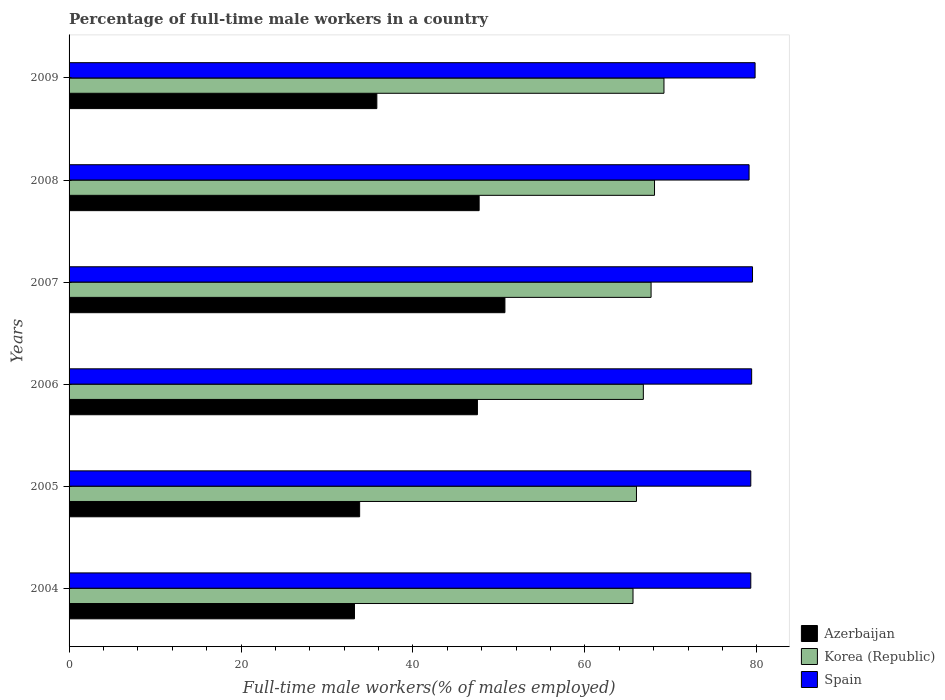How many groups of bars are there?
Make the answer very short. 6. How many bars are there on the 4th tick from the top?
Your response must be concise. 3. Across all years, what is the maximum percentage of full-time male workers in Spain?
Keep it short and to the point. 79.8. Across all years, what is the minimum percentage of full-time male workers in Spain?
Offer a terse response. 79.1. What is the total percentage of full-time male workers in Azerbaijan in the graph?
Ensure brevity in your answer.  248.7. What is the difference between the percentage of full-time male workers in Korea (Republic) in 2005 and that in 2007?
Offer a very short reply. -1.7. What is the difference between the percentage of full-time male workers in Azerbaijan in 2004 and the percentage of full-time male workers in Korea (Republic) in 2008?
Give a very brief answer. -34.9. What is the average percentage of full-time male workers in Korea (Republic) per year?
Keep it short and to the point. 67.23. In the year 2005, what is the difference between the percentage of full-time male workers in Korea (Republic) and percentage of full-time male workers in Spain?
Your answer should be compact. -13.3. In how many years, is the percentage of full-time male workers in Azerbaijan greater than 36 %?
Your answer should be compact. 3. What is the ratio of the percentage of full-time male workers in Korea (Republic) in 2006 to that in 2007?
Provide a succinct answer. 0.99. Is the sum of the percentage of full-time male workers in Spain in 2004 and 2009 greater than the maximum percentage of full-time male workers in Azerbaijan across all years?
Ensure brevity in your answer.  Yes. What does the 1st bar from the top in 2006 represents?
Your answer should be compact. Spain. What does the 1st bar from the bottom in 2007 represents?
Your response must be concise. Azerbaijan. Are all the bars in the graph horizontal?
Give a very brief answer. Yes. Does the graph contain any zero values?
Give a very brief answer. No. How many legend labels are there?
Provide a short and direct response. 3. What is the title of the graph?
Your answer should be compact. Percentage of full-time male workers in a country. What is the label or title of the X-axis?
Make the answer very short. Full-time male workers(% of males employed). What is the label or title of the Y-axis?
Keep it short and to the point. Years. What is the Full-time male workers(% of males employed) of Azerbaijan in 2004?
Keep it short and to the point. 33.2. What is the Full-time male workers(% of males employed) of Korea (Republic) in 2004?
Your answer should be compact. 65.6. What is the Full-time male workers(% of males employed) of Spain in 2004?
Provide a succinct answer. 79.3. What is the Full-time male workers(% of males employed) in Azerbaijan in 2005?
Give a very brief answer. 33.8. What is the Full-time male workers(% of males employed) of Spain in 2005?
Your response must be concise. 79.3. What is the Full-time male workers(% of males employed) in Azerbaijan in 2006?
Provide a short and direct response. 47.5. What is the Full-time male workers(% of males employed) in Korea (Republic) in 2006?
Make the answer very short. 66.8. What is the Full-time male workers(% of males employed) in Spain in 2006?
Offer a terse response. 79.4. What is the Full-time male workers(% of males employed) in Azerbaijan in 2007?
Make the answer very short. 50.7. What is the Full-time male workers(% of males employed) in Korea (Republic) in 2007?
Offer a terse response. 67.7. What is the Full-time male workers(% of males employed) of Spain in 2007?
Your answer should be very brief. 79.5. What is the Full-time male workers(% of males employed) of Azerbaijan in 2008?
Your answer should be compact. 47.7. What is the Full-time male workers(% of males employed) in Korea (Republic) in 2008?
Your response must be concise. 68.1. What is the Full-time male workers(% of males employed) of Spain in 2008?
Provide a short and direct response. 79.1. What is the Full-time male workers(% of males employed) of Azerbaijan in 2009?
Ensure brevity in your answer.  35.8. What is the Full-time male workers(% of males employed) of Korea (Republic) in 2009?
Give a very brief answer. 69.2. What is the Full-time male workers(% of males employed) in Spain in 2009?
Provide a succinct answer. 79.8. Across all years, what is the maximum Full-time male workers(% of males employed) of Azerbaijan?
Ensure brevity in your answer.  50.7. Across all years, what is the maximum Full-time male workers(% of males employed) in Korea (Republic)?
Offer a terse response. 69.2. Across all years, what is the maximum Full-time male workers(% of males employed) of Spain?
Give a very brief answer. 79.8. Across all years, what is the minimum Full-time male workers(% of males employed) in Azerbaijan?
Your answer should be compact. 33.2. Across all years, what is the minimum Full-time male workers(% of males employed) in Korea (Republic)?
Give a very brief answer. 65.6. Across all years, what is the minimum Full-time male workers(% of males employed) in Spain?
Give a very brief answer. 79.1. What is the total Full-time male workers(% of males employed) in Azerbaijan in the graph?
Give a very brief answer. 248.7. What is the total Full-time male workers(% of males employed) of Korea (Republic) in the graph?
Your answer should be very brief. 403.4. What is the total Full-time male workers(% of males employed) of Spain in the graph?
Give a very brief answer. 476.4. What is the difference between the Full-time male workers(% of males employed) of Azerbaijan in 2004 and that in 2005?
Your response must be concise. -0.6. What is the difference between the Full-time male workers(% of males employed) of Korea (Republic) in 2004 and that in 2005?
Ensure brevity in your answer.  -0.4. What is the difference between the Full-time male workers(% of males employed) of Azerbaijan in 2004 and that in 2006?
Offer a terse response. -14.3. What is the difference between the Full-time male workers(% of males employed) of Korea (Republic) in 2004 and that in 2006?
Provide a short and direct response. -1.2. What is the difference between the Full-time male workers(% of males employed) of Spain in 2004 and that in 2006?
Your response must be concise. -0.1. What is the difference between the Full-time male workers(% of males employed) of Azerbaijan in 2004 and that in 2007?
Your answer should be very brief. -17.5. What is the difference between the Full-time male workers(% of males employed) in Spain in 2004 and that in 2007?
Offer a very short reply. -0.2. What is the difference between the Full-time male workers(% of males employed) of Azerbaijan in 2004 and that in 2008?
Offer a terse response. -14.5. What is the difference between the Full-time male workers(% of males employed) in Spain in 2004 and that in 2008?
Ensure brevity in your answer.  0.2. What is the difference between the Full-time male workers(% of males employed) in Azerbaijan in 2004 and that in 2009?
Keep it short and to the point. -2.6. What is the difference between the Full-time male workers(% of males employed) of Spain in 2004 and that in 2009?
Provide a short and direct response. -0.5. What is the difference between the Full-time male workers(% of males employed) of Azerbaijan in 2005 and that in 2006?
Your answer should be compact. -13.7. What is the difference between the Full-time male workers(% of males employed) of Azerbaijan in 2005 and that in 2007?
Offer a terse response. -16.9. What is the difference between the Full-time male workers(% of males employed) in Korea (Republic) in 2005 and that in 2007?
Your response must be concise. -1.7. What is the difference between the Full-time male workers(% of males employed) of Azerbaijan in 2005 and that in 2009?
Your response must be concise. -2. What is the difference between the Full-time male workers(% of males employed) of Azerbaijan in 2006 and that in 2008?
Your answer should be compact. -0.2. What is the difference between the Full-time male workers(% of males employed) of Korea (Republic) in 2006 and that in 2008?
Keep it short and to the point. -1.3. What is the difference between the Full-time male workers(% of males employed) in Spain in 2006 and that in 2008?
Offer a very short reply. 0.3. What is the difference between the Full-time male workers(% of males employed) of Spain in 2006 and that in 2009?
Provide a short and direct response. -0.4. What is the difference between the Full-time male workers(% of males employed) of Azerbaijan in 2007 and that in 2008?
Your answer should be very brief. 3. What is the difference between the Full-time male workers(% of males employed) in Azerbaijan in 2007 and that in 2009?
Offer a very short reply. 14.9. What is the difference between the Full-time male workers(% of males employed) of Korea (Republic) in 2007 and that in 2009?
Make the answer very short. -1.5. What is the difference between the Full-time male workers(% of males employed) of Spain in 2007 and that in 2009?
Provide a succinct answer. -0.3. What is the difference between the Full-time male workers(% of males employed) of Azerbaijan in 2008 and that in 2009?
Give a very brief answer. 11.9. What is the difference between the Full-time male workers(% of males employed) of Spain in 2008 and that in 2009?
Ensure brevity in your answer.  -0.7. What is the difference between the Full-time male workers(% of males employed) of Azerbaijan in 2004 and the Full-time male workers(% of males employed) of Korea (Republic) in 2005?
Provide a short and direct response. -32.8. What is the difference between the Full-time male workers(% of males employed) of Azerbaijan in 2004 and the Full-time male workers(% of males employed) of Spain in 2005?
Keep it short and to the point. -46.1. What is the difference between the Full-time male workers(% of males employed) in Korea (Republic) in 2004 and the Full-time male workers(% of males employed) in Spain in 2005?
Ensure brevity in your answer.  -13.7. What is the difference between the Full-time male workers(% of males employed) in Azerbaijan in 2004 and the Full-time male workers(% of males employed) in Korea (Republic) in 2006?
Make the answer very short. -33.6. What is the difference between the Full-time male workers(% of males employed) of Azerbaijan in 2004 and the Full-time male workers(% of males employed) of Spain in 2006?
Provide a succinct answer. -46.2. What is the difference between the Full-time male workers(% of males employed) in Azerbaijan in 2004 and the Full-time male workers(% of males employed) in Korea (Republic) in 2007?
Your response must be concise. -34.5. What is the difference between the Full-time male workers(% of males employed) in Azerbaijan in 2004 and the Full-time male workers(% of males employed) in Spain in 2007?
Your answer should be very brief. -46.3. What is the difference between the Full-time male workers(% of males employed) in Azerbaijan in 2004 and the Full-time male workers(% of males employed) in Korea (Republic) in 2008?
Provide a short and direct response. -34.9. What is the difference between the Full-time male workers(% of males employed) of Azerbaijan in 2004 and the Full-time male workers(% of males employed) of Spain in 2008?
Ensure brevity in your answer.  -45.9. What is the difference between the Full-time male workers(% of males employed) of Korea (Republic) in 2004 and the Full-time male workers(% of males employed) of Spain in 2008?
Offer a very short reply. -13.5. What is the difference between the Full-time male workers(% of males employed) in Azerbaijan in 2004 and the Full-time male workers(% of males employed) in Korea (Republic) in 2009?
Provide a short and direct response. -36. What is the difference between the Full-time male workers(% of males employed) in Azerbaijan in 2004 and the Full-time male workers(% of males employed) in Spain in 2009?
Keep it short and to the point. -46.6. What is the difference between the Full-time male workers(% of males employed) in Azerbaijan in 2005 and the Full-time male workers(% of males employed) in Korea (Republic) in 2006?
Make the answer very short. -33. What is the difference between the Full-time male workers(% of males employed) of Azerbaijan in 2005 and the Full-time male workers(% of males employed) of Spain in 2006?
Offer a terse response. -45.6. What is the difference between the Full-time male workers(% of males employed) in Azerbaijan in 2005 and the Full-time male workers(% of males employed) in Korea (Republic) in 2007?
Your answer should be compact. -33.9. What is the difference between the Full-time male workers(% of males employed) of Azerbaijan in 2005 and the Full-time male workers(% of males employed) of Spain in 2007?
Give a very brief answer. -45.7. What is the difference between the Full-time male workers(% of males employed) in Azerbaijan in 2005 and the Full-time male workers(% of males employed) in Korea (Republic) in 2008?
Keep it short and to the point. -34.3. What is the difference between the Full-time male workers(% of males employed) of Azerbaijan in 2005 and the Full-time male workers(% of males employed) of Spain in 2008?
Provide a short and direct response. -45.3. What is the difference between the Full-time male workers(% of males employed) in Azerbaijan in 2005 and the Full-time male workers(% of males employed) in Korea (Republic) in 2009?
Offer a very short reply. -35.4. What is the difference between the Full-time male workers(% of males employed) in Azerbaijan in 2005 and the Full-time male workers(% of males employed) in Spain in 2009?
Your response must be concise. -46. What is the difference between the Full-time male workers(% of males employed) in Azerbaijan in 2006 and the Full-time male workers(% of males employed) in Korea (Republic) in 2007?
Your answer should be compact. -20.2. What is the difference between the Full-time male workers(% of males employed) of Azerbaijan in 2006 and the Full-time male workers(% of males employed) of Spain in 2007?
Provide a succinct answer. -32. What is the difference between the Full-time male workers(% of males employed) in Azerbaijan in 2006 and the Full-time male workers(% of males employed) in Korea (Republic) in 2008?
Ensure brevity in your answer.  -20.6. What is the difference between the Full-time male workers(% of males employed) in Azerbaijan in 2006 and the Full-time male workers(% of males employed) in Spain in 2008?
Provide a short and direct response. -31.6. What is the difference between the Full-time male workers(% of males employed) of Azerbaijan in 2006 and the Full-time male workers(% of males employed) of Korea (Republic) in 2009?
Your answer should be very brief. -21.7. What is the difference between the Full-time male workers(% of males employed) in Azerbaijan in 2006 and the Full-time male workers(% of males employed) in Spain in 2009?
Offer a terse response. -32.3. What is the difference between the Full-time male workers(% of males employed) of Korea (Republic) in 2006 and the Full-time male workers(% of males employed) of Spain in 2009?
Provide a short and direct response. -13. What is the difference between the Full-time male workers(% of males employed) in Azerbaijan in 2007 and the Full-time male workers(% of males employed) in Korea (Republic) in 2008?
Provide a short and direct response. -17.4. What is the difference between the Full-time male workers(% of males employed) in Azerbaijan in 2007 and the Full-time male workers(% of males employed) in Spain in 2008?
Give a very brief answer. -28.4. What is the difference between the Full-time male workers(% of males employed) in Korea (Republic) in 2007 and the Full-time male workers(% of males employed) in Spain in 2008?
Your answer should be compact. -11.4. What is the difference between the Full-time male workers(% of males employed) of Azerbaijan in 2007 and the Full-time male workers(% of males employed) of Korea (Republic) in 2009?
Your answer should be very brief. -18.5. What is the difference between the Full-time male workers(% of males employed) in Azerbaijan in 2007 and the Full-time male workers(% of males employed) in Spain in 2009?
Make the answer very short. -29.1. What is the difference between the Full-time male workers(% of males employed) in Korea (Republic) in 2007 and the Full-time male workers(% of males employed) in Spain in 2009?
Provide a succinct answer. -12.1. What is the difference between the Full-time male workers(% of males employed) in Azerbaijan in 2008 and the Full-time male workers(% of males employed) in Korea (Republic) in 2009?
Ensure brevity in your answer.  -21.5. What is the difference between the Full-time male workers(% of males employed) in Azerbaijan in 2008 and the Full-time male workers(% of males employed) in Spain in 2009?
Your response must be concise. -32.1. What is the average Full-time male workers(% of males employed) in Azerbaijan per year?
Your answer should be very brief. 41.45. What is the average Full-time male workers(% of males employed) of Korea (Republic) per year?
Keep it short and to the point. 67.23. What is the average Full-time male workers(% of males employed) in Spain per year?
Your answer should be very brief. 79.4. In the year 2004, what is the difference between the Full-time male workers(% of males employed) in Azerbaijan and Full-time male workers(% of males employed) in Korea (Republic)?
Keep it short and to the point. -32.4. In the year 2004, what is the difference between the Full-time male workers(% of males employed) in Azerbaijan and Full-time male workers(% of males employed) in Spain?
Offer a very short reply. -46.1. In the year 2004, what is the difference between the Full-time male workers(% of males employed) of Korea (Republic) and Full-time male workers(% of males employed) of Spain?
Your response must be concise. -13.7. In the year 2005, what is the difference between the Full-time male workers(% of males employed) in Azerbaijan and Full-time male workers(% of males employed) in Korea (Republic)?
Make the answer very short. -32.2. In the year 2005, what is the difference between the Full-time male workers(% of males employed) in Azerbaijan and Full-time male workers(% of males employed) in Spain?
Your answer should be very brief. -45.5. In the year 2005, what is the difference between the Full-time male workers(% of males employed) of Korea (Republic) and Full-time male workers(% of males employed) of Spain?
Your answer should be compact. -13.3. In the year 2006, what is the difference between the Full-time male workers(% of males employed) of Azerbaijan and Full-time male workers(% of males employed) of Korea (Republic)?
Provide a succinct answer. -19.3. In the year 2006, what is the difference between the Full-time male workers(% of males employed) in Azerbaijan and Full-time male workers(% of males employed) in Spain?
Offer a very short reply. -31.9. In the year 2007, what is the difference between the Full-time male workers(% of males employed) of Azerbaijan and Full-time male workers(% of males employed) of Korea (Republic)?
Give a very brief answer. -17. In the year 2007, what is the difference between the Full-time male workers(% of males employed) in Azerbaijan and Full-time male workers(% of males employed) in Spain?
Keep it short and to the point. -28.8. In the year 2007, what is the difference between the Full-time male workers(% of males employed) of Korea (Republic) and Full-time male workers(% of males employed) of Spain?
Provide a short and direct response. -11.8. In the year 2008, what is the difference between the Full-time male workers(% of males employed) in Azerbaijan and Full-time male workers(% of males employed) in Korea (Republic)?
Offer a very short reply. -20.4. In the year 2008, what is the difference between the Full-time male workers(% of males employed) in Azerbaijan and Full-time male workers(% of males employed) in Spain?
Keep it short and to the point. -31.4. In the year 2009, what is the difference between the Full-time male workers(% of males employed) of Azerbaijan and Full-time male workers(% of males employed) of Korea (Republic)?
Your response must be concise. -33.4. In the year 2009, what is the difference between the Full-time male workers(% of males employed) in Azerbaijan and Full-time male workers(% of males employed) in Spain?
Your response must be concise. -44. In the year 2009, what is the difference between the Full-time male workers(% of males employed) of Korea (Republic) and Full-time male workers(% of males employed) of Spain?
Offer a terse response. -10.6. What is the ratio of the Full-time male workers(% of males employed) in Azerbaijan in 2004 to that in 2005?
Make the answer very short. 0.98. What is the ratio of the Full-time male workers(% of males employed) of Spain in 2004 to that in 2005?
Provide a succinct answer. 1. What is the ratio of the Full-time male workers(% of males employed) of Azerbaijan in 2004 to that in 2006?
Offer a terse response. 0.7. What is the ratio of the Full-time male workers(% of males employed) of Korea (Republic) in 2004 to that in 2006?
Make the answer very short. 0.98. What is the ratio of the Full-time male workers(% of males employed) of Azerbaijan in 2004 to that in 2007?
Your response must be concise. 0.65. What is the ratio of the Full-time male workers(% of males employed) of Korea (Republic) in 2004 to that in 2007?
Make the answer very short. 0.97. What is the ratio of the Full-time male workers(% of males employed) of Azerbaijan in 2004 to that in 2008?
Your answer should be very brief. 0.7. What is the ratio of the Full-time male workers(% of males employed) of Korea (Republic) in 2004 to that in 2008?
Your response must be concise. 0.96. What is the ratio of the Full-time male workers(% of males employed) in Spain in 2004 to that in 2008?
Make the answer very short. 1. What is the ratio of the Full-time male workers(% of males employed) in Azerbaijan in 2004 to that in 2009?
Give a very brief answer. 0.93. What is the ratio of the Full-time male workers(% of males employed) in Korea (Republic) in 2004 to that in 2009?
Make the answer very short. 0.95. What is the ratio of the Full-time male workers(% of males employed) in Azerbaijan in 2005 to that in 2006?
Your answer should be very brief. 0.71. What is the ratio of the Full-time male workers(% of males employed) of Korea (Republic) in 2005 to that in 2006?
Your answer should be very brief. 0.99. What is the ratio of the Full-time male workers(% of males employed) in Azerbaijan in 2005 to that in 2007?
Offer a very short reply. 0.67. What is the ratio of the Full-time male workers(% of males employed) of Korea (Republic) in 2005 to that in 2007?
Offer a terse response. 0.97. What is the ratio of the Full-time male workers(% of males employed) in Spain in 2005 to that in 2007?
Offer a terse response. 1. What is the ratio of the Full-time male workers(% of males employed) of Azerbaijan in 2005 to that in 2008?
Offer a very short reply. 0.71. What is the ratio of the Full-time male workers(% of males employed) of Korea (Republic) in 2005 to that in 2008?
Ensure brevity in your answer.  0.97. What is the ratio of the Full-time male workers(% of males employed) of Azerbaijan in 2005 to that in 2009?
Offer a terse response. 0.94. What is the ratio of the Full-time male workers(% of males employed) of Korea (Republic) in 2005 to that in 2009?
Keep it short and to the point. 0.95. What is the ratio of the Full-time male workers(% of males employed) of Azerbaijan in 2006 to that in 2007?
Your response must be concise. 0.94. What is the ratio of the Full-time male workers(% of males employed) in Korea (Republic) in 2006 to that in 2007?
Give a very brief answer. 0.99. What is the ratio of the Full-time male workers(% of males employed) in Spain in 2006 to that in 2007?
Keep it short and to the point. 1. What is the ratio of the Full-time male workers(% of males employed) in Korea (Republic) in 2006 to that in 2008?
Your answer should be very brief. 0.98. What is the ratio of the Full-time male workers(% of males employed) of Spain in 2006 to that in 2008?
Provide a succinct answer. 1. What is the ratio of the Full-time male workers(% of males employed) of Azerbaijan in 2006 to that in 2009?
Offer a very short reply. 1.33. What is the ratio of the Full-time male workers(% of males employed) of Korea (Republic) in 2006 to that in 2009?
Your response must be concise. 0.97. What is the ratio of the Full-time male workers(% of males employed) in Azerbaijan in 2007 to that in 2008?
Offer a very short reply. 1.06. What is the ratio of the Full-time male workers(% of males employed) in Azerbaijan in 2007 to that in 2009?
Make the answer very short. 1.42. What is the ratio of the Full-time male workers(% of males employed) in Korea (Republic) in 2007 to that in 2009?
Give a very brief answer. 0.98. What is the ratio of the Full-time male workers(% of males employed) of Spain in 2007 to that in 2009?
Keep it short and to the point. 1. What is the ratio of the Full-time male workers(% of males employed) of Azerbaijan in 2008 to that in 2009?
Offer a terse response. 1.33. What is the ratio of the Full-time male workers(% of males employed) in Korea (Republic) in 2008 to that in 2009?
Keep it short and to the point. 0.98. What is the ratio of the Full-time male workers(% of males employed) of Spain in 2008 to that in 2009?
Offer a very short reply. 0.99. What is the difference between the highest and the second highest Full-time male workers(% of males employed) of Korea (Republic)?
Your answer should be very brief. 1.1. What is the difference between the highest and the second highest Full-time male workers(% of males employed) in Spain?
Give a very brief answer. 0.3. What is the difference between the highest and the lowest Full-time male workers(% of males employed) of Azerbaijan?
Your response must be concise. 17.5. 